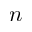<formula> <loc_0><loc_0><loc_500><loc_500>n</formula> 